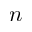<formula> <loc_0><loc_0><loc_500><loc_500>n</formula> 